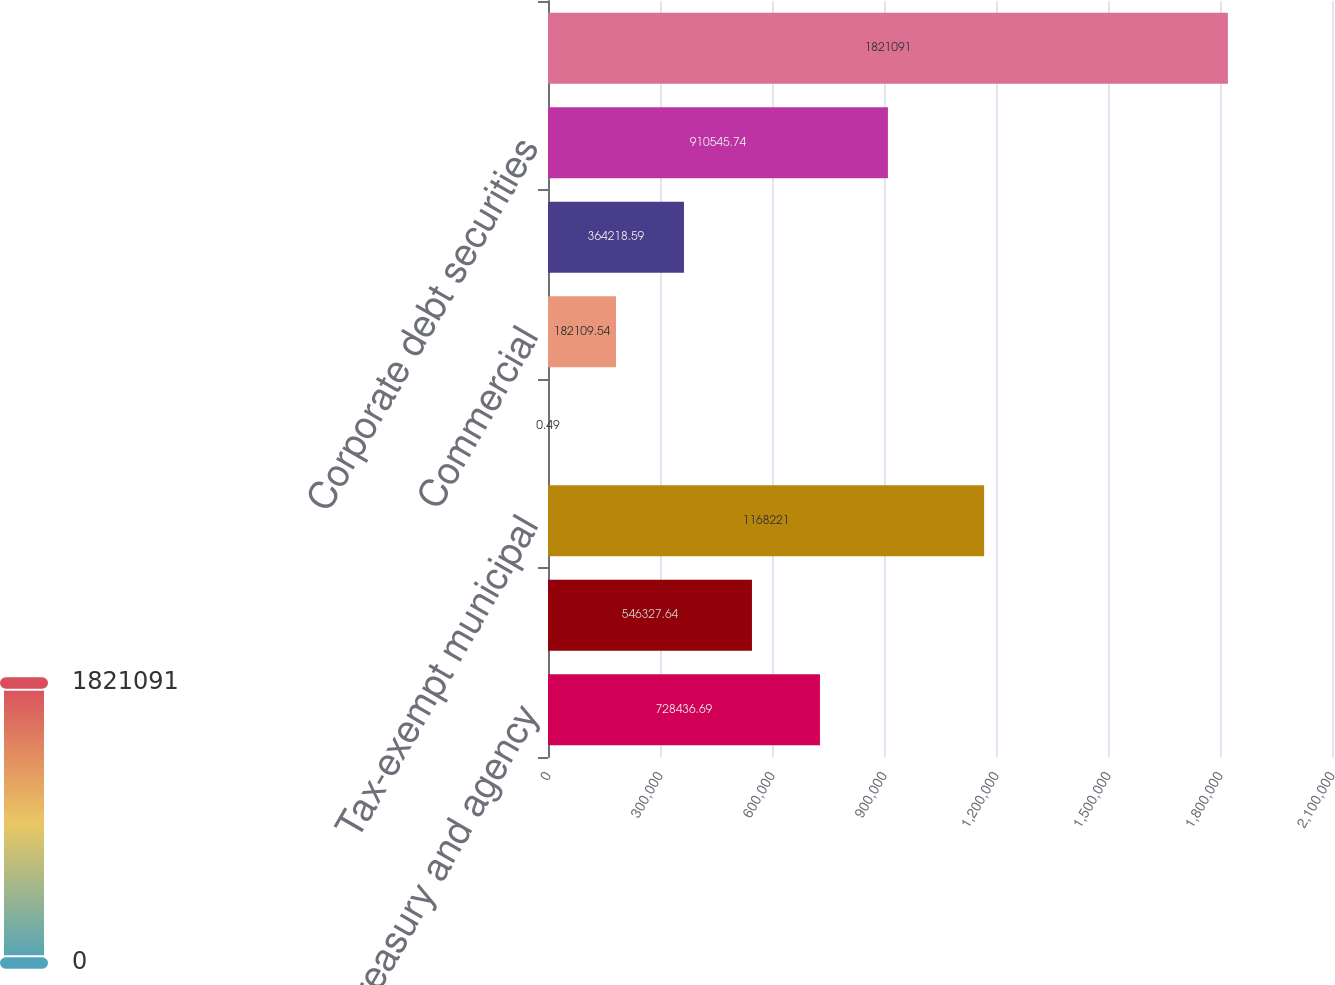Convert chart. <chart><loc_0><loc_0><loc_500><loc_500><bar_chart><fcel>US Treasury and agency<fcel>Mortgage-backed securities<fcel>Tax-exempt municipal<fcel>Residential<fcel>Commercial<fcel>Asset-backed securities<fcel>Corporate debt securities<fcel>Total debt securities<nl><fcel>728437<fcel>546328<fcel>1.16822e+06<fcel>0.49<fcel>182110<fcel>364219<fcel>910546<fcel>1.82109e+06<nl></chart> 